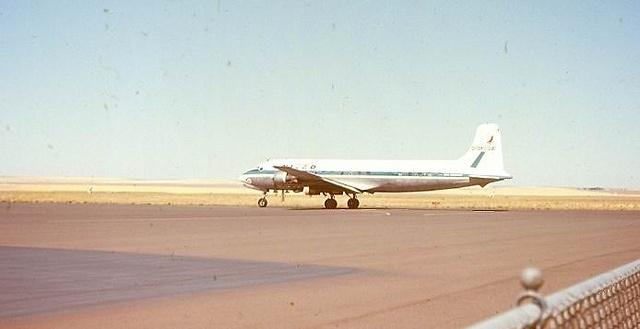Describe the objects in this image and their specific colors. I can see a airplane in lightblue, ivory, darkgray, gray, and maroon tones in this image. 